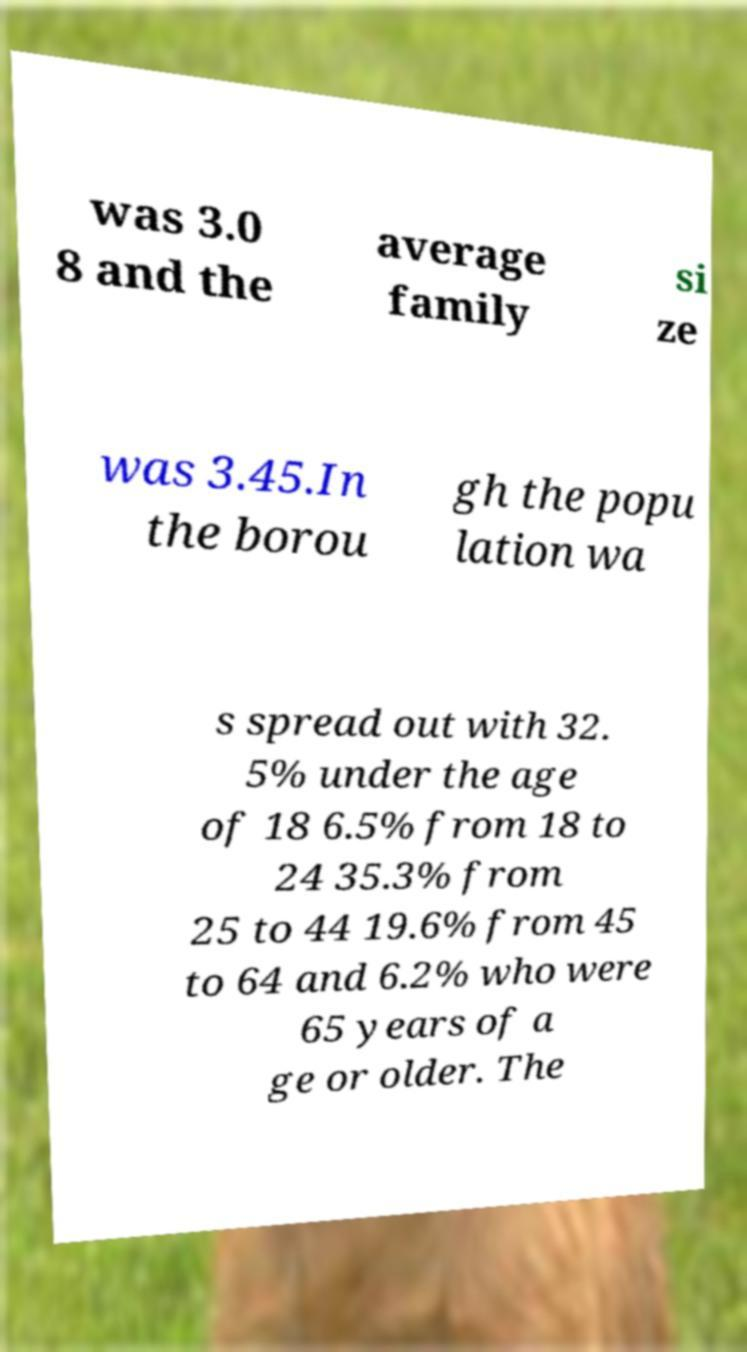Please read and relay the text visible in this image. What does it say? was 3.0 8 and the average family si ze was 3.45.In the borou gh the popu lation wa s spread out with 32. 5% under the age of 18 6.5% from 18 to 24 35.3% from 25 to 44 19.6% from 45 to 64 and 6.2% who were 65 years of a ge or older. The 